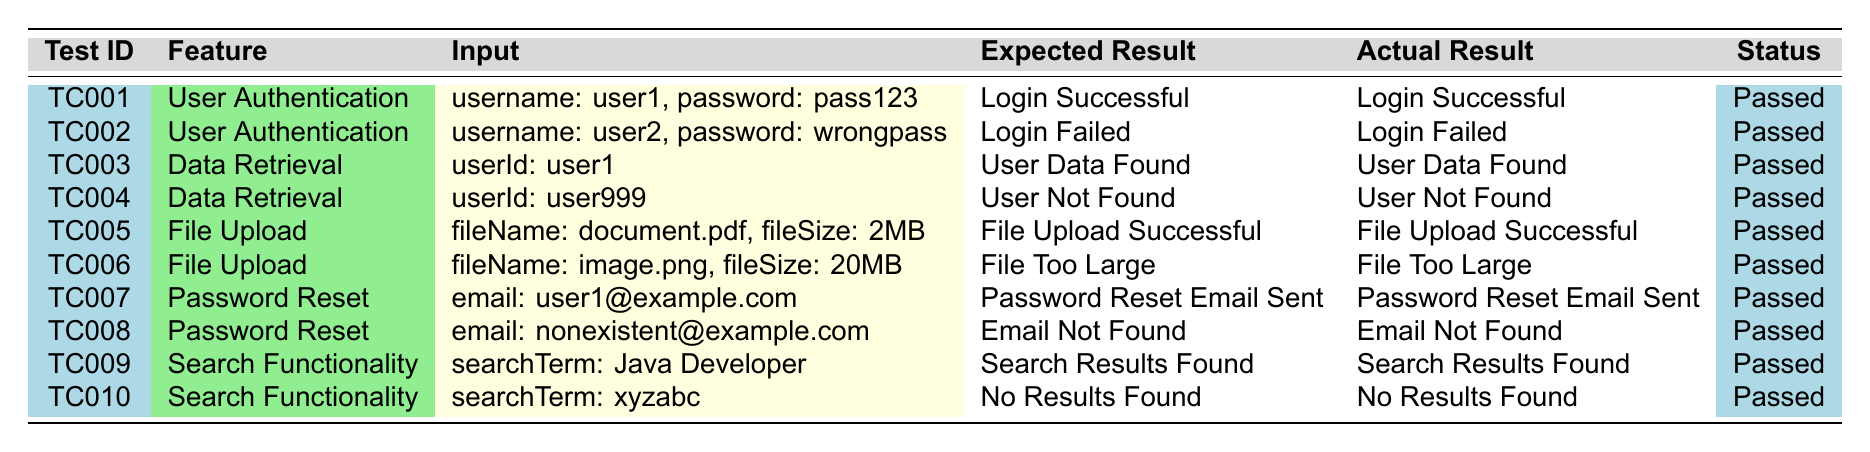What is the test case ID for the test that checks user authentication with valid credentials? Looking at the table, TC001 is the test case ID for the feature 'User Authentication' where the input is 'username: user1, password: pass123' and both the expected and actual results are 'Login Successful'.
Answer: TC001 How many test cases have a status of "Passed"? By reviewing the "Status" column in the table, all 10 test cases have a "Passed" status, as each one indicates "Passed".
Answer: 10 What is the expected result for TC006? Referring to the table, TC006 is for the 'File Upload' feature and the expected result listed is 'File Too Large'.
Answer: File Too Large Did TC005 pass or fail? The table shows that TC005, which is related to 'File Upload', has a status of 'Passed', indicating it was successful.
Answer: Passed Which feature has the highest number of test cases? Analyzing the "Feature" column, 'User Authentication' and 'File Upload' both have 2 test cases each, but all others (Data Retrieval, Password Reset, and Search Functionality) have 2 each as well. This means there is a tie among several features with 2 test cases each.
Answer: Tie among User Authentication, File Upload, Data Retrieval, Password Reset, Search Functionality What is the actual result when searching for "Java Developer"? Looking at TC009 in the "Search Functionality" category, the actual result is 'Search Results Found'.
Answer: Search Results Found How many test cases are related to password reset functionality? From the table, reviewing the "Feature" column, there are 2 test cases, TC007 and TC008, that correspond to the 'Password Reset' feature.
Answer: 2 Is there any test case that failed? Upon reviewing the "Status" column, all test cases have a status of 'Passed', indicating no failures were reported.
Answer: No Which test case had an input of email for an email that does not exist? In the table, TC008 is the test case that tests for an email address 'nonexistent@example.com’, where the expected and actual results both are 'Email Not Found'.
Answer: TC008 What are the expected results of the tests for user authentication? Looking at TC001 and TC002 in the 'User Authentication' feature, the expected results are 'Login Successful' for TC001 and 'Login Failed' for TC002. Combined, they indicate that expected results vary based on the input validity.
Answer: Login Successful, Login Failed 